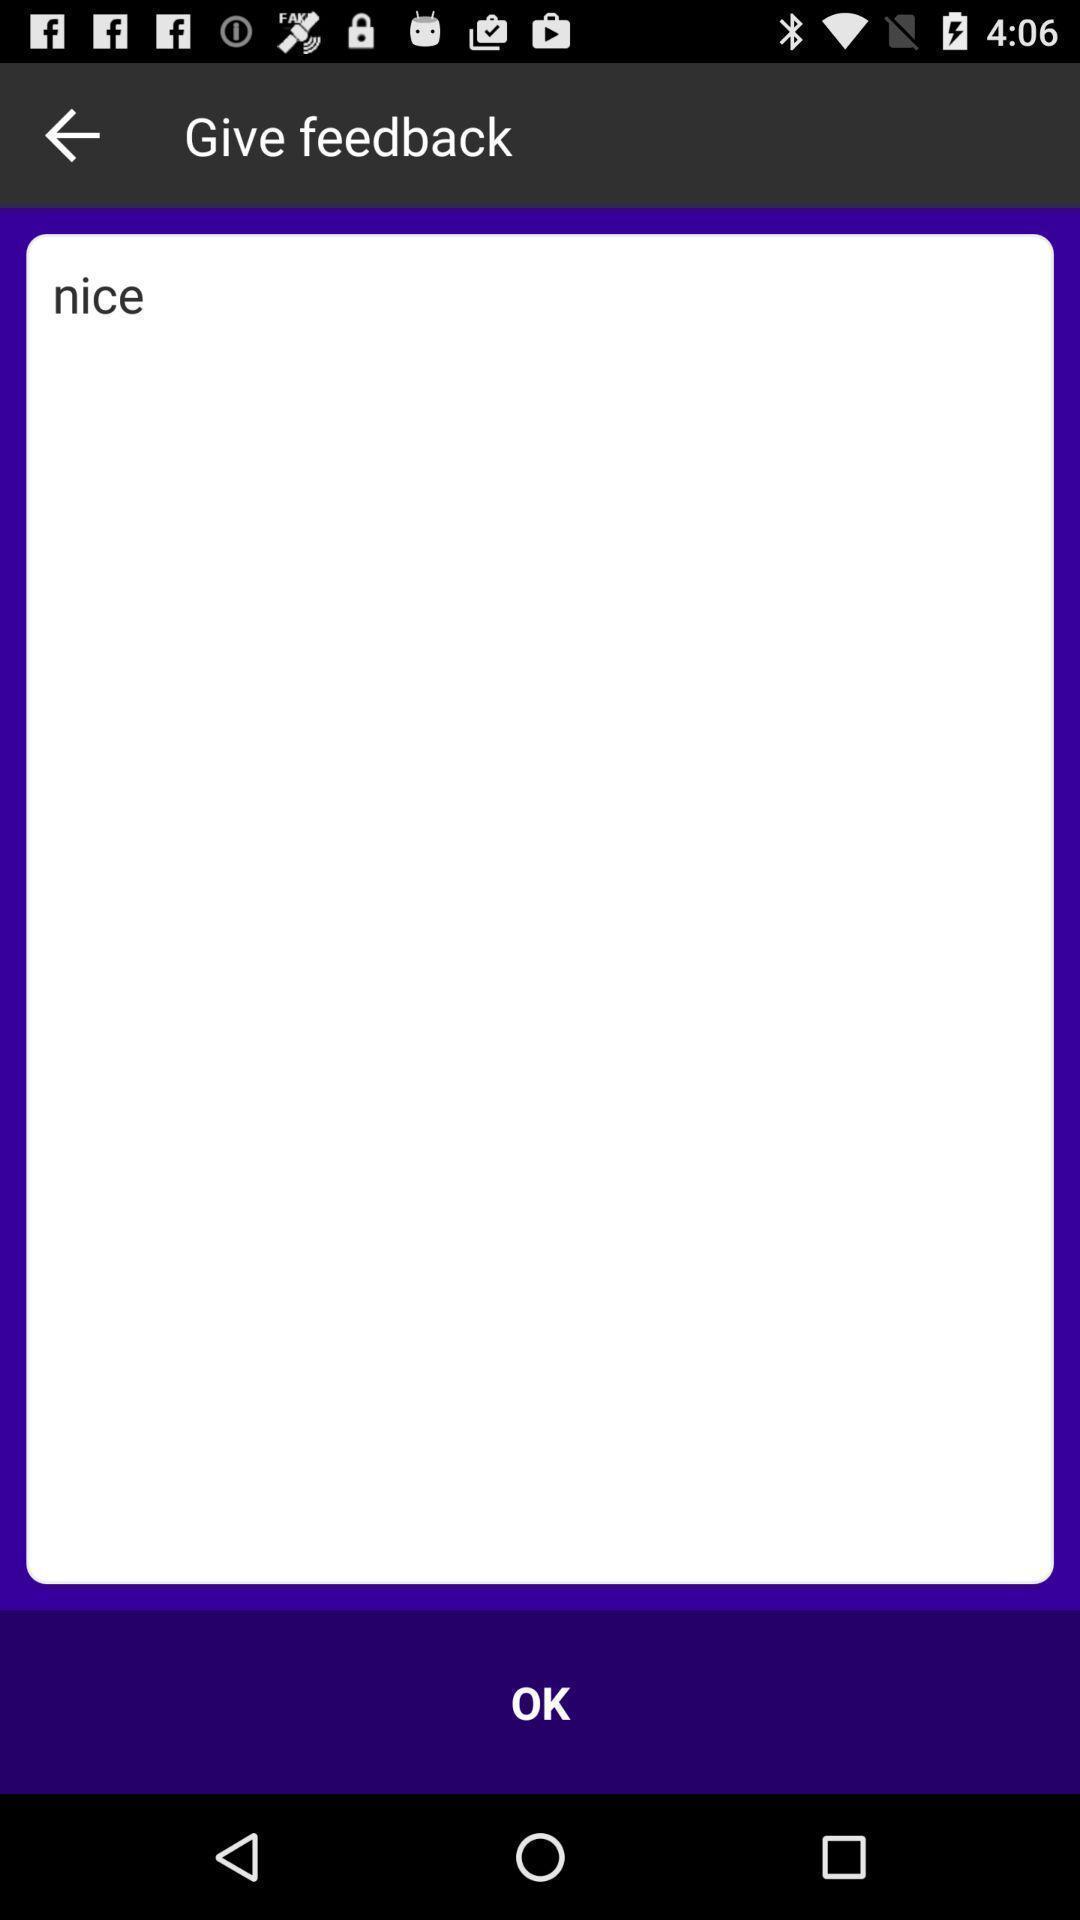Provide a description of this screenshot. Screen displaying the feedback page. 